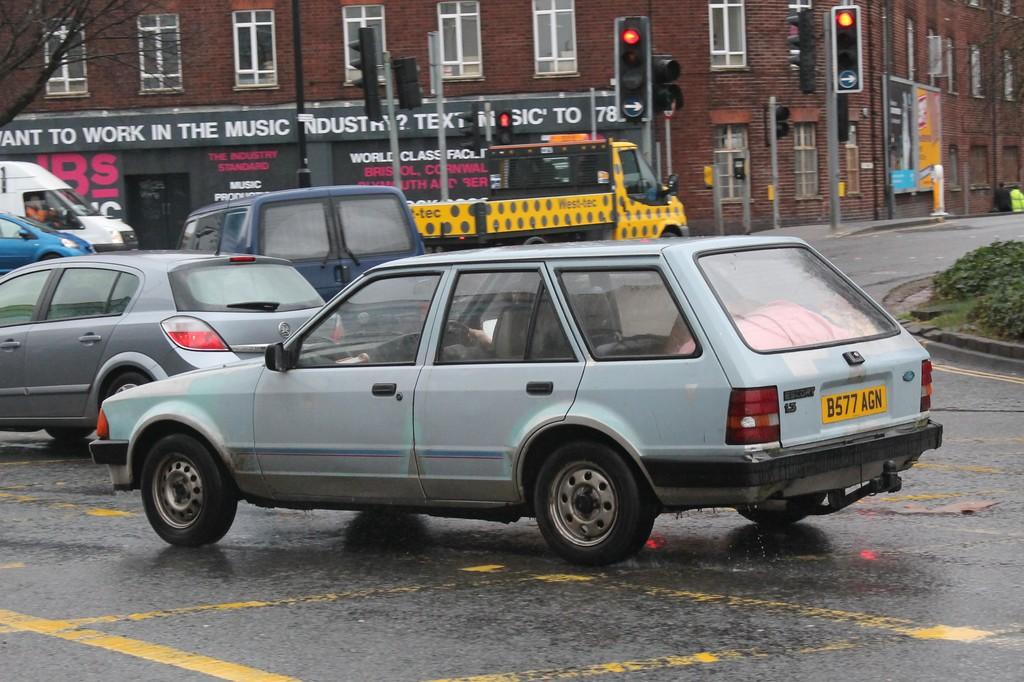<image>
Offer a succinct explanation of the picture presented. Several cars drive past a business asking if you want to work in the music industry. 